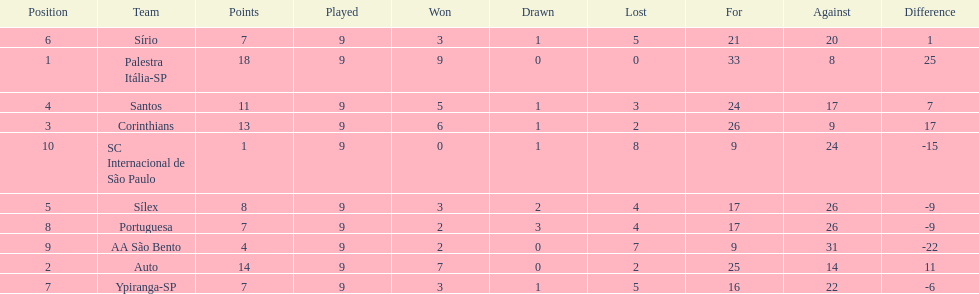How many teams had more points than silex? 4. 